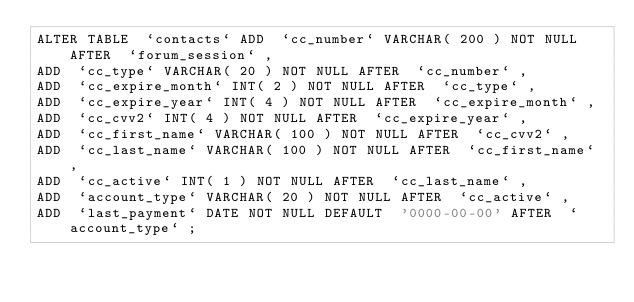<code> <loc_0><loc_0><loc_500><loc_500><_SQL_>ALTER TABLE  `contacts` ADD  `cc_number` VARCHAR( 200 ) NOT NULL AFTER  `forum_session` ,
ADD  `cc_type` VARCHAR( 20 ) NOT NULL AFTER  `cc_number` ,
ADD  `cc_expire_month` INT( 2 ) NOT NULL AFTER  `cc_type` ,
ADD  `cc_expire_year` INT( 4 ) NOT NULL AFTER  `cc_expire_month` ,
ADD  `cc_cvv2` INT( 4 ) NOT NULL AFTER  `cc_expire_year` ,
ADD  `cc_first_name` VARCHAR( 100 ) NOT NULL AFTER  `cc_cvv2` ,
ADD  `cc_last_name` VARCHAR( 100 ) NOT NULL AFTER  `cc_first_name` ,
ADD  `cc_active` INT( 1 ) NOT NULL AFTER  `cc_last_name` ,
ADD  `account_type` VARCHAR( 20 ) NOT NULL AFTER  `cc_active` ,
ADD  `last_payment` DATE NOT NULL DEFAULT  '0000-00-00' AFTER  `account_type` ;</code> 